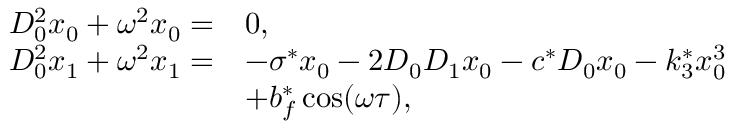Convert formula to latex. <formula><loc_0><loc_0><loc_500><loc_500>\begin{array} { r l } { D _ { 0 } ^ { 2 } x _ { 0 } + \omega ^ { 2 } x _ { 0 } = } & { 0 , } \\ { D _ { 0 } ^ { 2 } x _ { 1 } + \omega ^ { 2 } x _ { 1 } = } & { - \sigma ^ { * } x _ { 0 } - 2 D _ { 0 } D _ { 1 } x _ { 0 } - c ^ { * } D _ { 0 } x _ { 0 } - k _ { 3 } ^ { * } x _ { 0 } ^ { 3 } } \\ & { + b _ { f } ^ { * } \cos ( \omega \tau ) , } \end{array}</formula> 